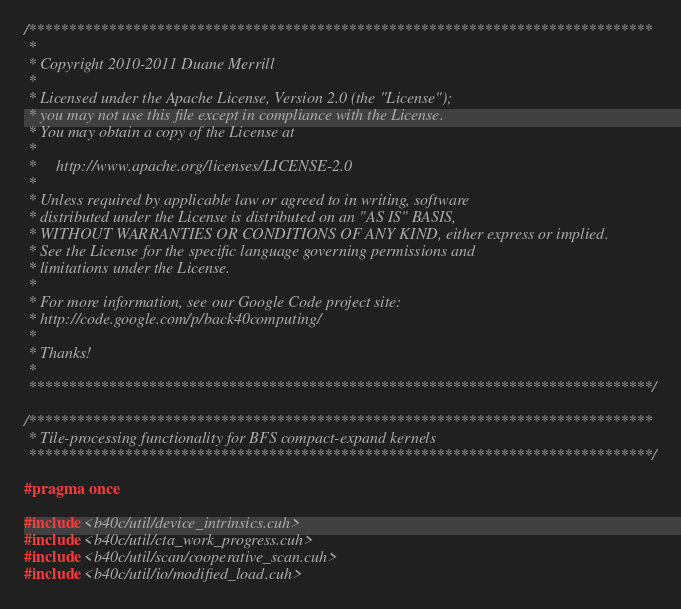Convert code to text. <code><loc_0><loc_0><loc_500><loc_500><_Cuda_>/******************************************************************************
 * 
 * Copyright 2010-2011 Duane Merrill
 * 
 * Licensed under the Apache License, Version 2.0 (the "License");
 * you may not use this file except in compliance with the License.
 * You may obtain a copy of the License at
 * 
 *     http://www.apache.org/licenses/LICENSE-2.0
 *
 * Unless required by applicable law or agreed to in writing, software
 * distributed under the License is distributed on an "AS IS" BASIS,
 * WITHOUT WARRANTIES OR CONDITIONS OF ANY KIND, either express or implied.
 * See the License for the specific language governing permissions and
 * limitations under the License. 
 * 
 * For more information, see our Google Code project site: 
 * http://code.google.com/p/back40computing/
 * 
 * Thanks!
 * 
 ******************************************************************************/

/******************************************************************************
 * Tile-processing functionality for BFS compact-expand kernels
 ******************************************************************************/

#pragma once

#include <b40c/util/device_intrinsics.cuh>
#include <b40c/util/cta_work_progress.cuh>
#include <b40c/util/scan/cooperative_scan.cuh>
#include <b40c/util/io/modified_load.cuh></code> 